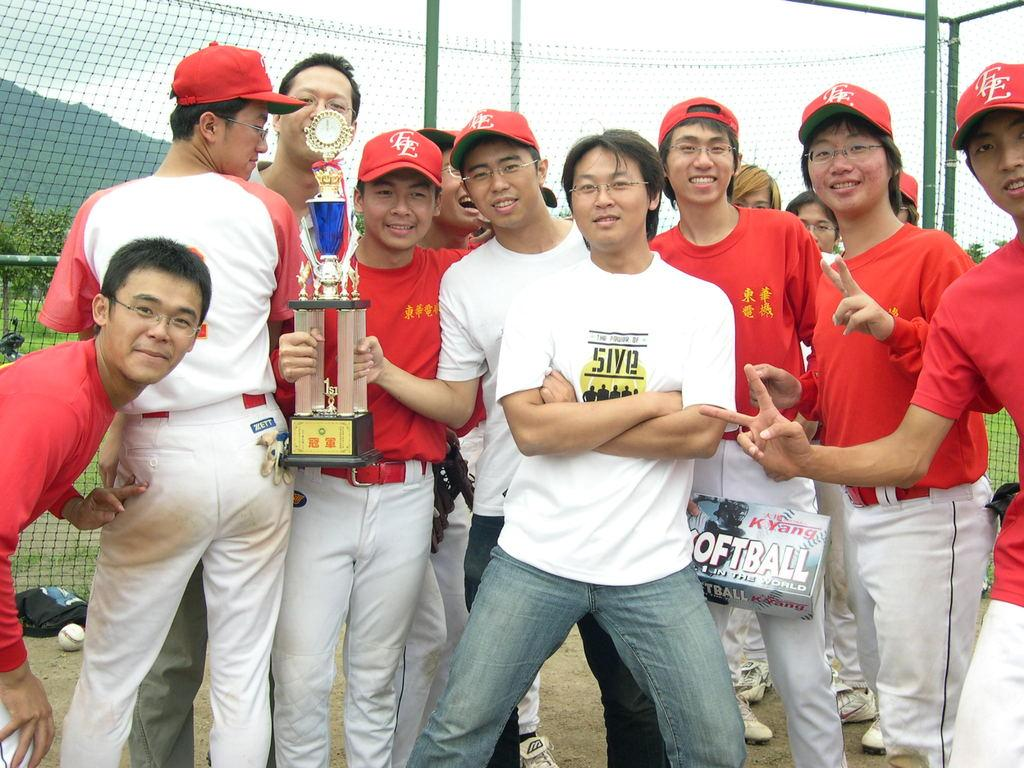<image>
Summarize the visual content of the image. softball players are standing with a trophy and wearing EE hats 